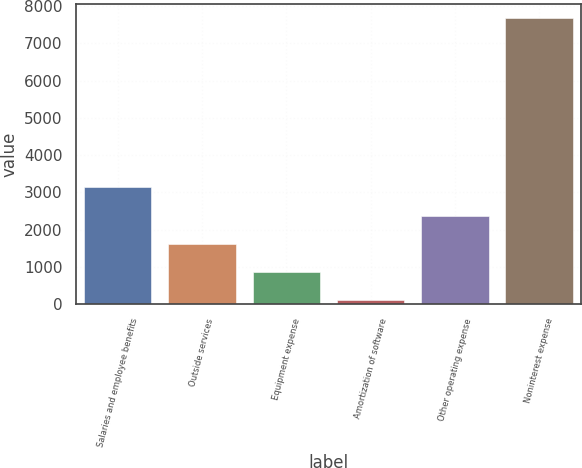Convert chart. <chart><loc_0><loc_0><loc_500><loc_500><bar_chart><fcel>Salaries and employee benefits<fcel>Outside services<fcel>Equipment expense<fcel>Amortization of software<fcel>Other operating expense<fcel>Noninterest expense<nl><fcel>3132.8<fcel>1617.4<fcel>859.7<fcel>102<fcel>2375.1<fcel>7679<nl></chart> 